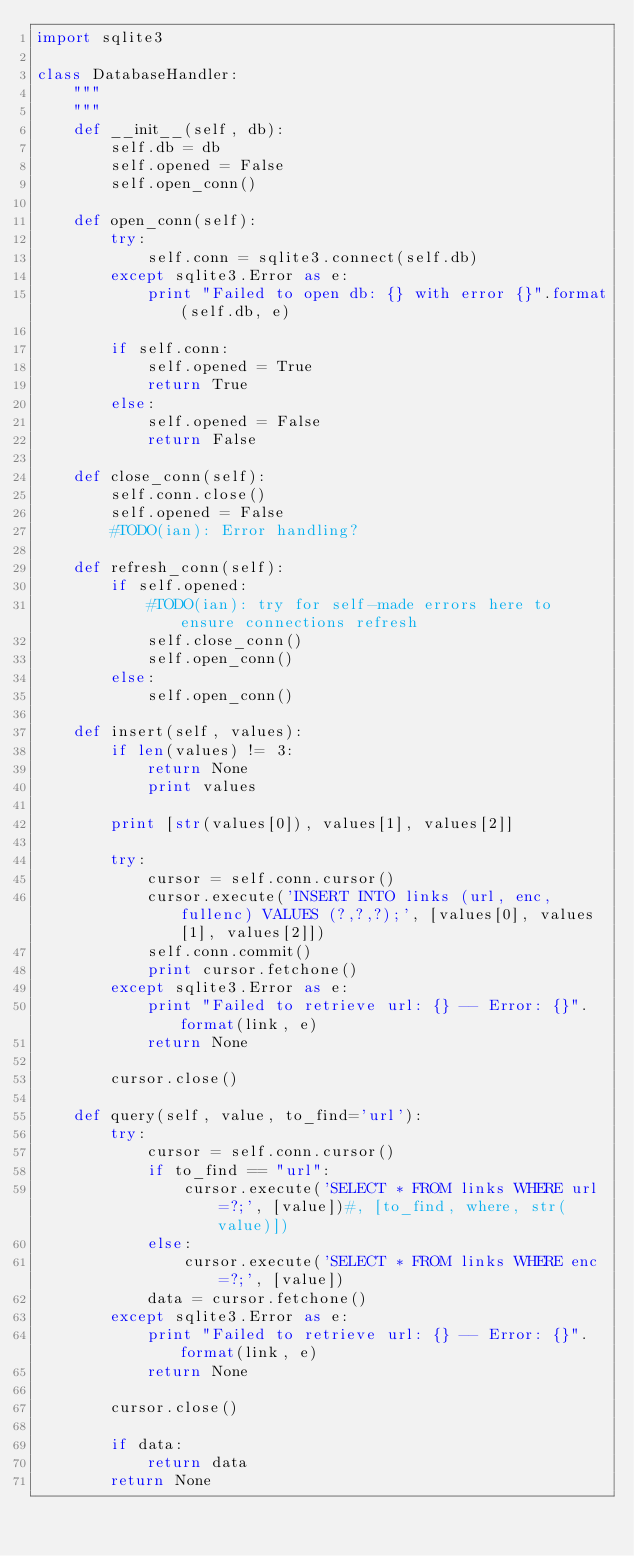<code> <loc_0><loc_0><loc_500><loc_500><_Python_>import sqlite3

class DatabaseHandler:
    """
    """
    def __init__(self, db):
        self.db = db
        self.opened = False
        self.open_conn()

    def open_conn(self):
        try:
            self.conn = sqlite3.connect(self.db)
        except sqlite3.Error as e:
            print "Failed to open db: {} with error {}".format(self.db, e)

        if self.conn:
            self.opened = True
            return True
        else:
            self.opened = False
            return False

    def close_conn(self):
        self.conn.close()
        self.opened = False
        #TODO(ian): Error handling?

    def refresh_conn(self):
        if self.opened:
            #TODO(ian): try for self-made errors here to ensure connections refresh
            self.close_conn()
            self.open_conn()
        else:
            self.open_conn()

    def insert(self, values):
        if len(values) != 3:
            return None
            print values

        print [str(values[0]), values[1], values[2]]

        try:
            cursor = self.conn.cursor()
            cursor.execute('INSERT INTO links (url, enc, fullenc) VALUES (?,?,?);', [values[0], values[1], values[2]])
            self.conn.commit()
            print cursor.fetchone()
        except sqlite3.Error as e:
            print "Failed to retrieve url: {} -- Error: {}".format(link, e)
            return None

        cursor.close()

    def query(self, value, to_find='url'):
        try:
            cursor = self.conn.cursor()
            if to_find == "url":
                cursor.execute('SELECT * FROM links WHERE url=?;', [value])#, [to_find, where, str(value)])
            else:
                cursor.execute('SELECT * FROM links WHERE enc=?;', [value])
            data = cursor.fetchone()
        except sqlite3.Error as e:
            print "Failed to retrieve url: {} -- Error: {}".format(link, e)
            return None

        cursor.close()

        if data:
            return data
        return None

</code> 